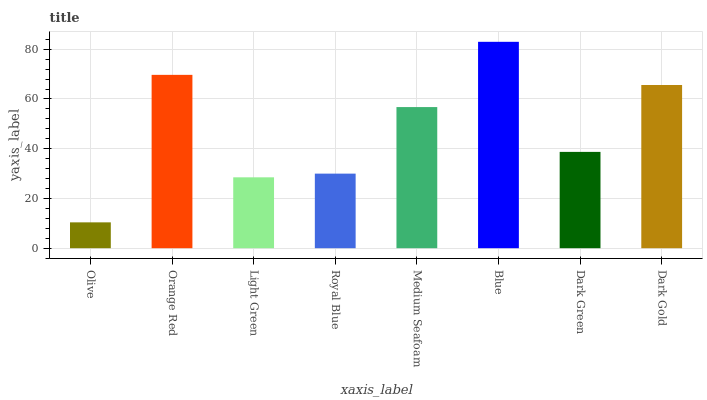Is Olive the minimum?
Answer yes or no. Yes. Is Blue the maximum?
Answer yes or no. Yes. Is Orange Red the minimum?
Answer yes or no. No. Is Orange Red the maximum?
Answer yes or no. No. Is Orange Red greater than Olive?
Answer yes or no. Yes. Is Olive less than Orange Red?
Answer yes or no. Yes. Is Olive greater than Orange Red?
Answer yes or no. No. Is Orange Red less than Olive?
Answer yes or no. No. Is Medium Seafoam the high median?
Answer yes or no. Yes. Is Dark Green the low median?
Answer yes or no. Yes. Is Light Green the high median?
Answer yes or no. No. Is Blue the low median?
Answer yes or no. No. 